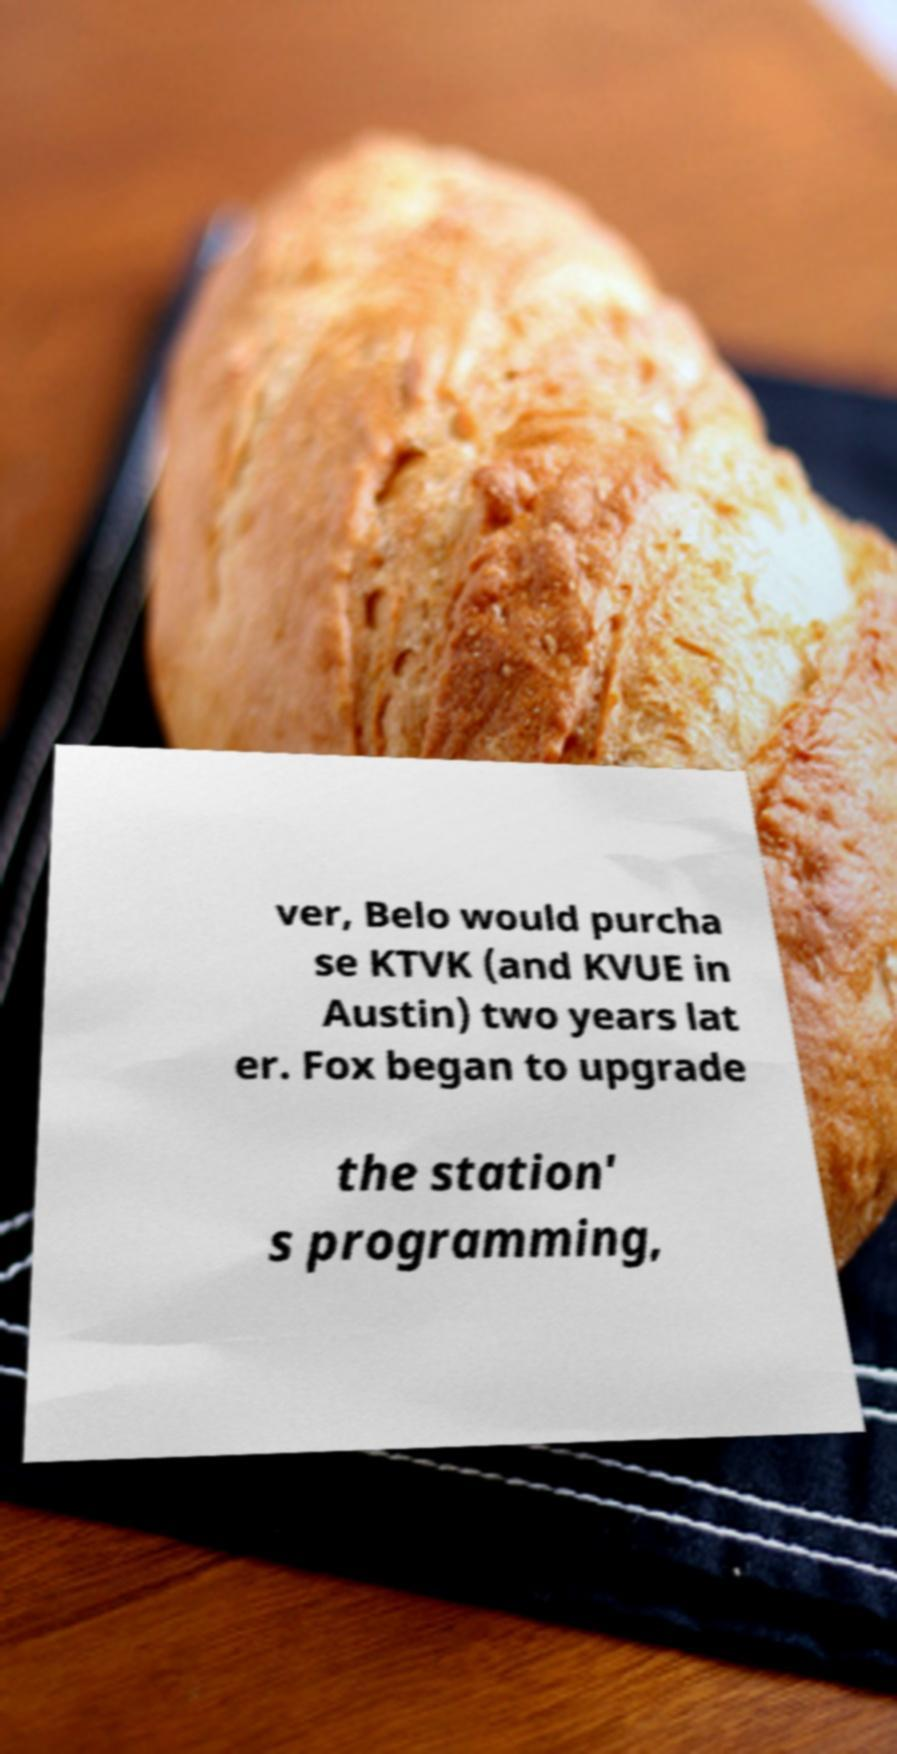Please identify and transcribe the text found in this image. ver, Belo would purcha se KTVK (and KVUE in Austin) two years lat er. Fox began to upgrade the station' s programming, 